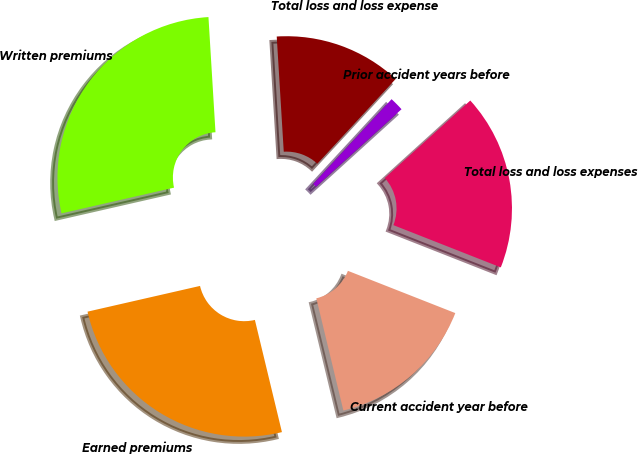Convert chart. <chart><loc_0><loc_0><loc_500><loc_500><pie_chart><fcel>Written premiums<fcel>Earned premiums<fcel>Current accident year before<fcel>Total loss and loss expenses<fcel>Prior accident years before<fcel>Total loss and loss expense<nl><fcel>27.61%<fcel>25.19%<fcel>15.27%<fcel>17.69%<fcel>1.4%<fcel>12.85%<nl></chart> 